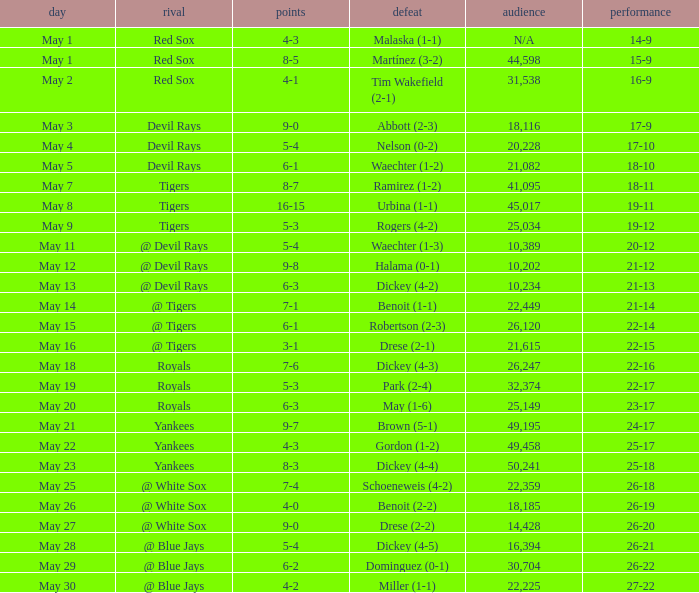What is the tally of the contest participated in by 25,034? 5-3. 